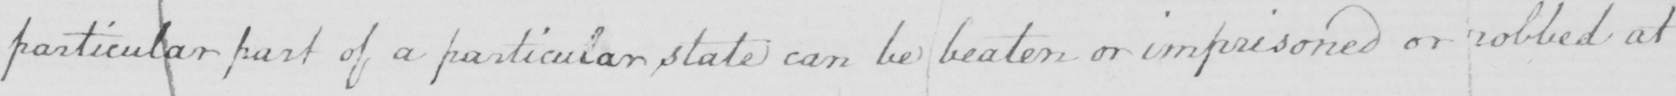Please provide the text content of this handwritten line. particular part of a particular state can be beaten or imprisoned or robbed at 